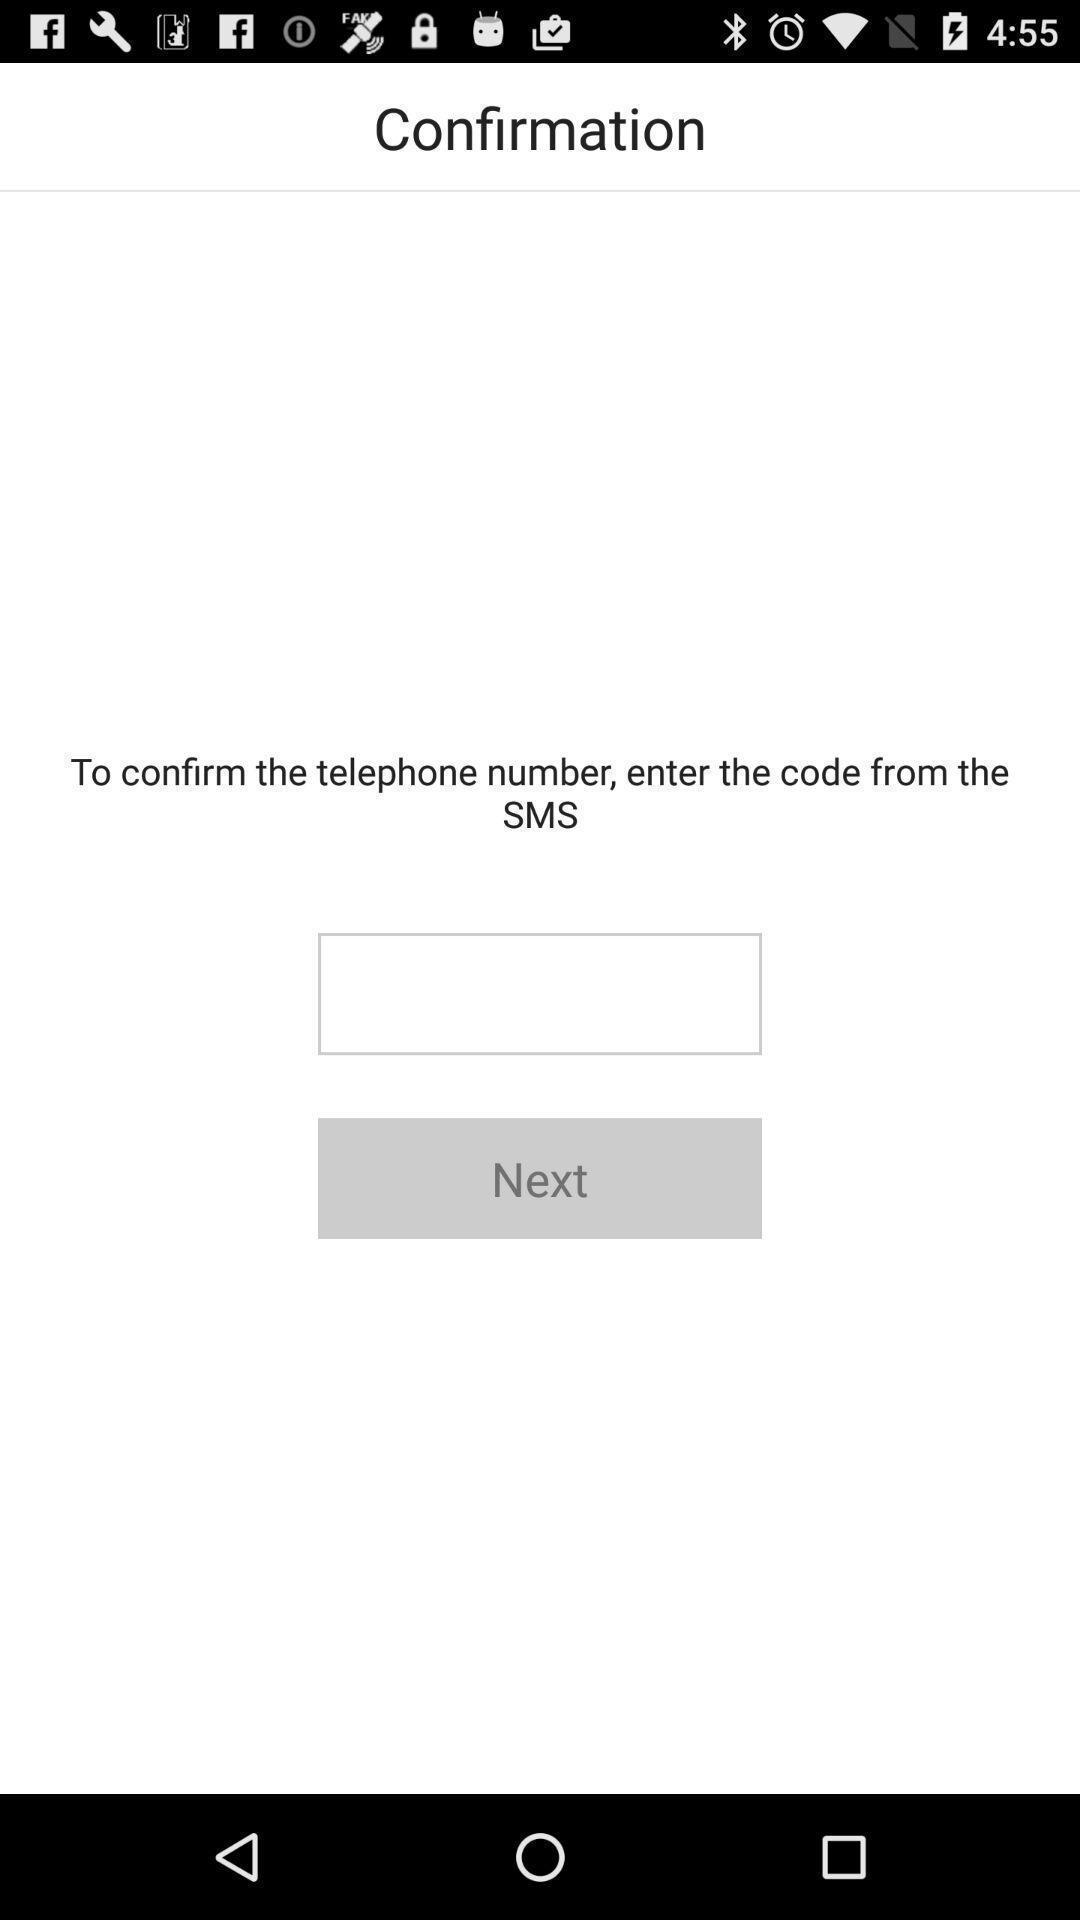Provide a textual representation of this image. Page displays to enter a code for confirmation in app. 